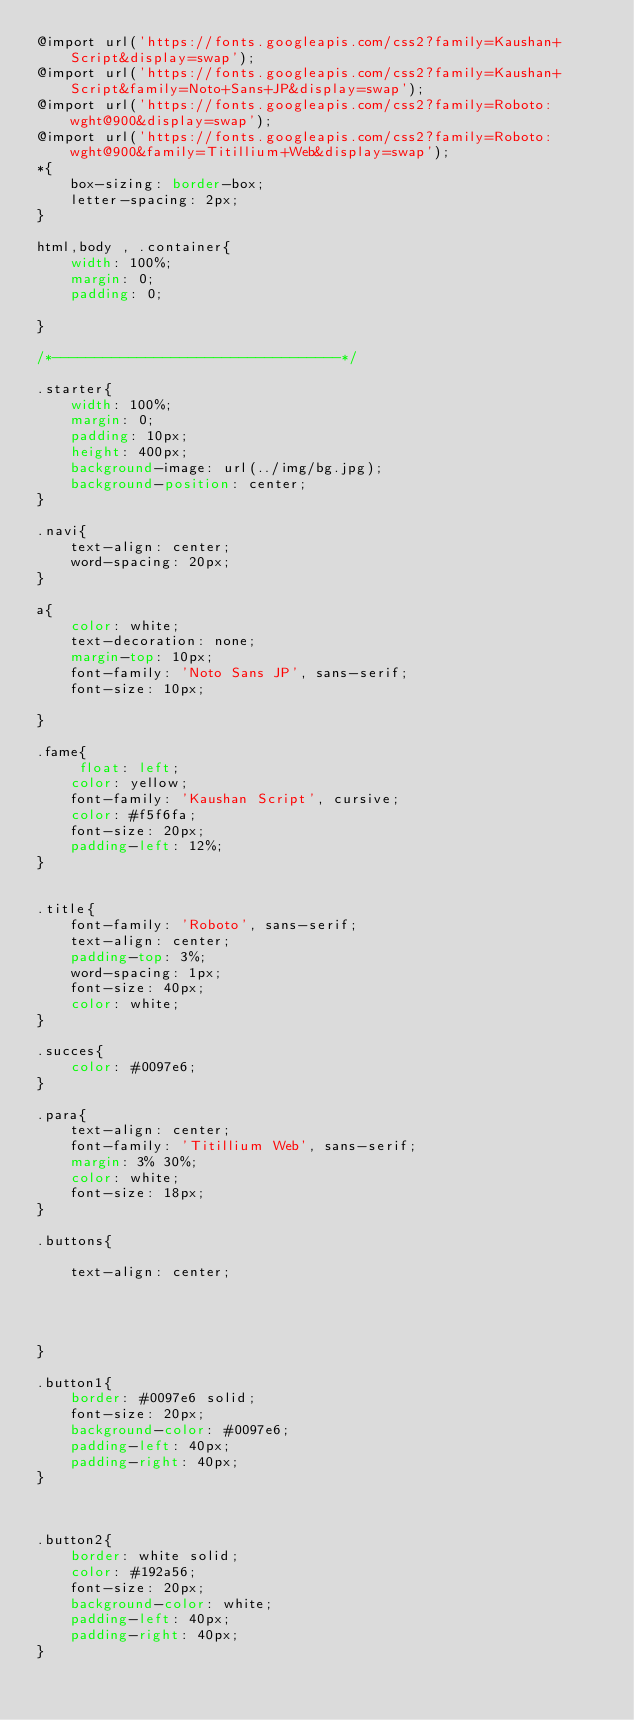Convert code to text. <code><loc_0><loc_0><loc_500><loc_500><_CSS_>@import url('https://fonts.googleapis.com/css2?family=Kaushan+Script&display=swap');
@import url('https://fonts.googleapis.com/css2?family=Kaushan+Script&family=Noto+Sans+JP&display=swap');
@import url('https://fonts.googleapis.com/css2?family=Roboto:wght@900&display=swap');
@import url('https://fonts.googleapis.com/css2?family=Roboto:wght@900&family=Titillium+Web&display=swap');
*{
    box-sizing: border-box;
    letter-spacing: 2px;
}

html,body , .container{
    width: 100%;
    margin: 0;
    padding: 0;

}

/*----------------------------------*/

.starter{
    width: 100%;
    margin: 0;
    padding: 10px;
    height: 400px;
    background-image: url(../img/bg.jpg);
    background-position: center;
}

.navi{
    text-align: center;
    word-spacing: 20px;
}

a{
    color: white;
    text-decoration: none;
    margin-top: 10px;
    font-family: 'Noto Sans JP', sans-serif;
    font-size: 10px;
   
}

.fame{
     float: left;
    color: yellow;
    font-family: 'Kaushan Script', cursive;
    color: #f5f6fa;
    font-size: 20px;
    padding-left: 12%;
}


.title{
    font-family: 'Roboto', sans-serif;
    text-align: center;
    padding-top: 3%;
    word-spacing: 1px;
    font-size: 40px;
    color: white;
}

.succes{
    color: #0097e6;
}

.para{
    text-align: center;
    font-family: 'Titillium Web', sans-serif;    
    margin: 3% 30%;
    color: white;   
    font-size: 18px;
}

.buttons{
    
    text-align: center;
    
    
    
 
}

.button1{
    border: #0097e6 solid; 
    font-size: 20px; 
    background-color: #0097e6;  
    padding-left: 40px;
    padding-right: 40px;
}



.button2{
    border: white solid;   
    color: #192a56;
    font-size: 20px; 
    background-color: white;
    padding-left: 40px;
    padding-right: 40px;       
}</code> 